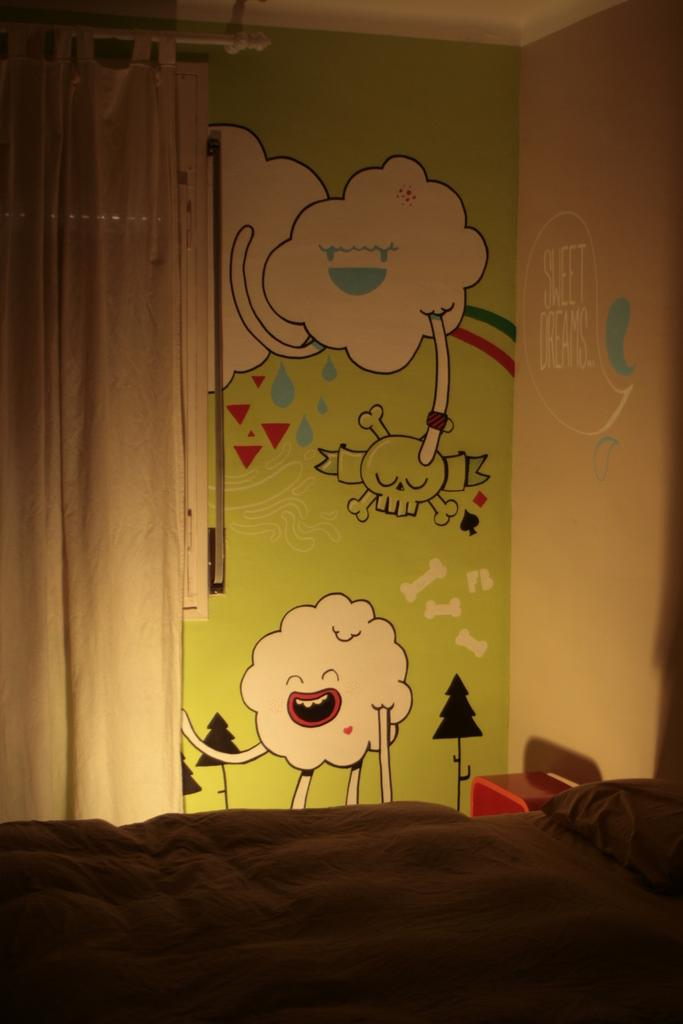What type of furniture is present in the image? There is a bed in the image. What can be seen in the background of the image? There are curtains in the background of the image. What is hanging on the wall in the image? There is a painting on the wall in the image. What is located in front of the wall in the image? There is an object in front of the wall in the image. Where is the pig located in the image? There is no pig present in the image. 